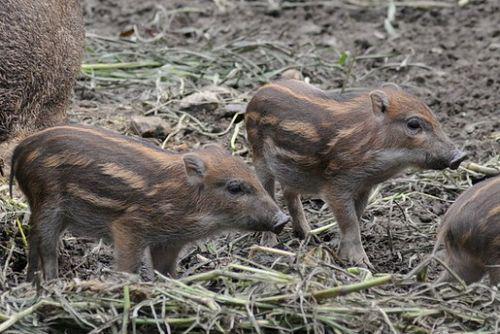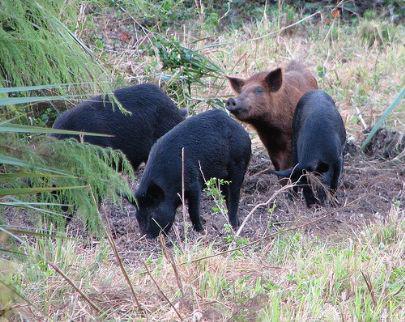The first image is the image on the left, the second image is the image on the right. Analyze the images presented: Is the assertion "In one image there is multiple striped pigs." valid? Answer yes or no. Yes. The first image is the image on the left, the second image is the image on the right. For the images shown, is this caption "there are at most 3 pigs in the image pair" true? Answer yes or no. No. 